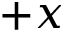Convert formula to latex. <formula><loc_0><loc_0><loc_500><loc_500>+ x</formula> 